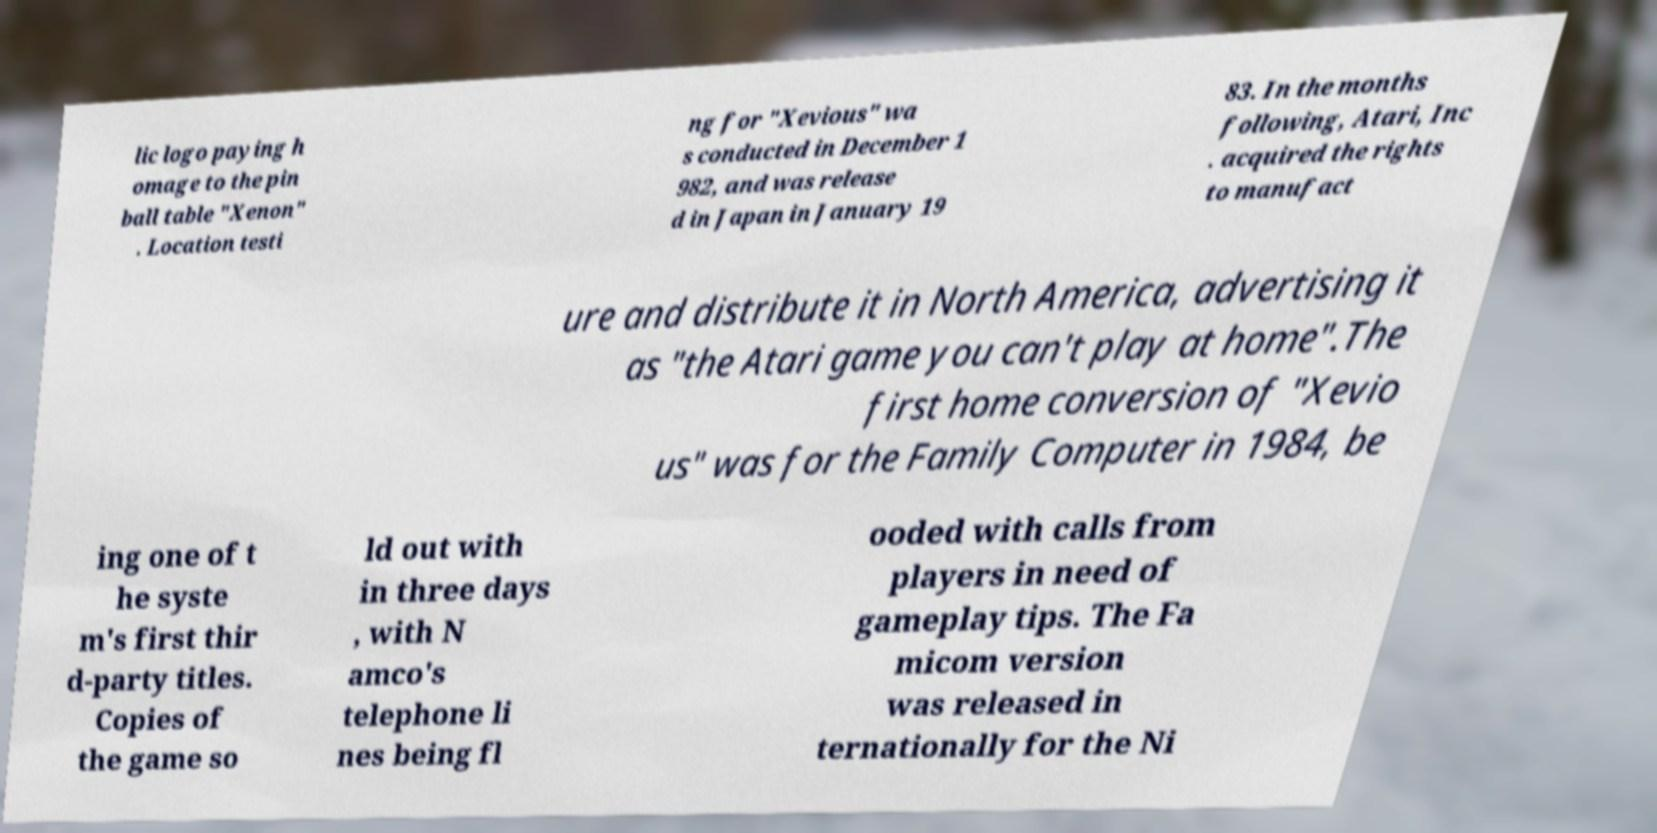Can you accurately transcribe the text from the provided image for me? lic logo paying h omage to the pin ball table "Xenon" . Location testi ng for "Xevious" wa s conducted in December 1 982, and was release d in Japan in January 19 83. In the months following, Atari, Inc . acquired the rights to manufact ure and distribute it in North America, advertising it as "the Atari game you can't play at home".The first home conversion of "Xevio us" was for the Family Computer in 1984, be ing one of t he syste m's first thir d-party titles. Copies of the game so ld out with in three days , with N amco's telephone li nes being fl ooded with calls from players in need of gameplay tips. The Fa micom version was released in ternationally for the Ni 